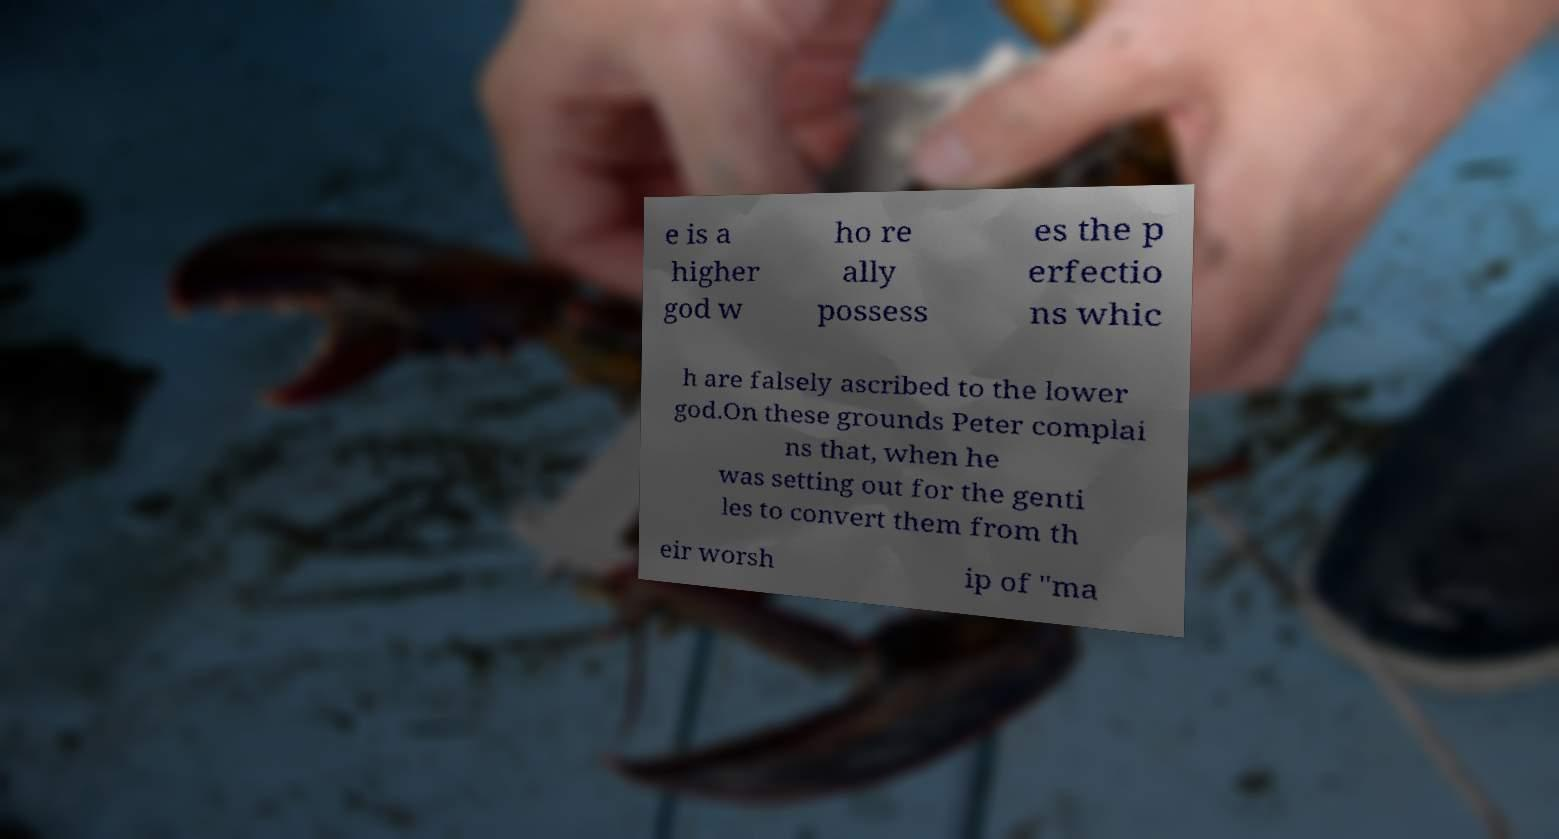Please identify and transcribe the text found in this image. e is a higher god w ho re ally possess es the p erfectio ns whic h are falsely ascribed to the lower god.On these grounds Peter complai ns that, when he was setting out for the genti les to convert them from th eir worsh ip of "ma 